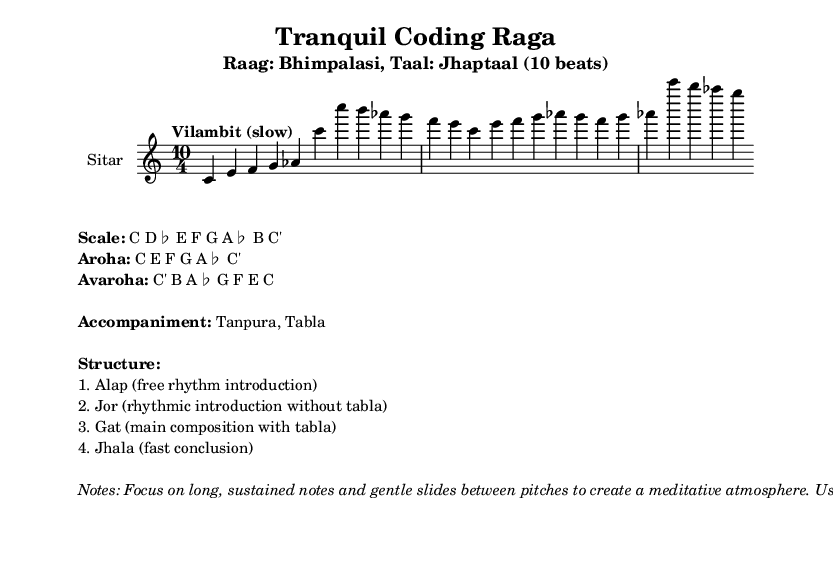What is the key signature of this music? The key signature is indicated at the beginning of the score. It is C major, which has no sharps or flats.
Answer: C major What is the time signature of this piece? The time signature is shown at the beginning of the score, giving the number of beats per measure and kind of note that gets the beat. Here, it is 10 beats per measure in Jhaptaal.
Answer: 10/4 What is the tempo marking of this piece? The tempo marking is located near the beginning of the score and indicates the speed of the music. It states "Vilambit (slow)", suggesting a slow tempo.
Answer: Vilambit (slow) What is the main instrument in this score? The main instrument is specified in the staff settings. It is labeled as "Sitar", which is a traditional Indian string instrument used for playing classical music.
Answer: Sitar What are the sections of the music structure? The structure is outlined in the markup at the bottom of the score. It describes the order of the sections as Alap, Jor, Gat, and Jhala. This gives a clear indication of how the performance will progress.
Answer: Alap, Jor, Gat, Jhala What is the Aroha of this raga? The Aroha is detailed in the markup and refers to the ascending scale of the raga. It lists the notes used when rising through the scale. For this piece, it is C E F G A♭ C'.
Answer: C E F G A♭ C' What kind of accompaniment is suggested for this piece? The accompaniment instruments are mentioned in the markup section under the "Accompaniment" label, specifying the instruments that should support the main melody, which are Tanpura and Tabla for this music.
Answer: Tanpura, Tabla 